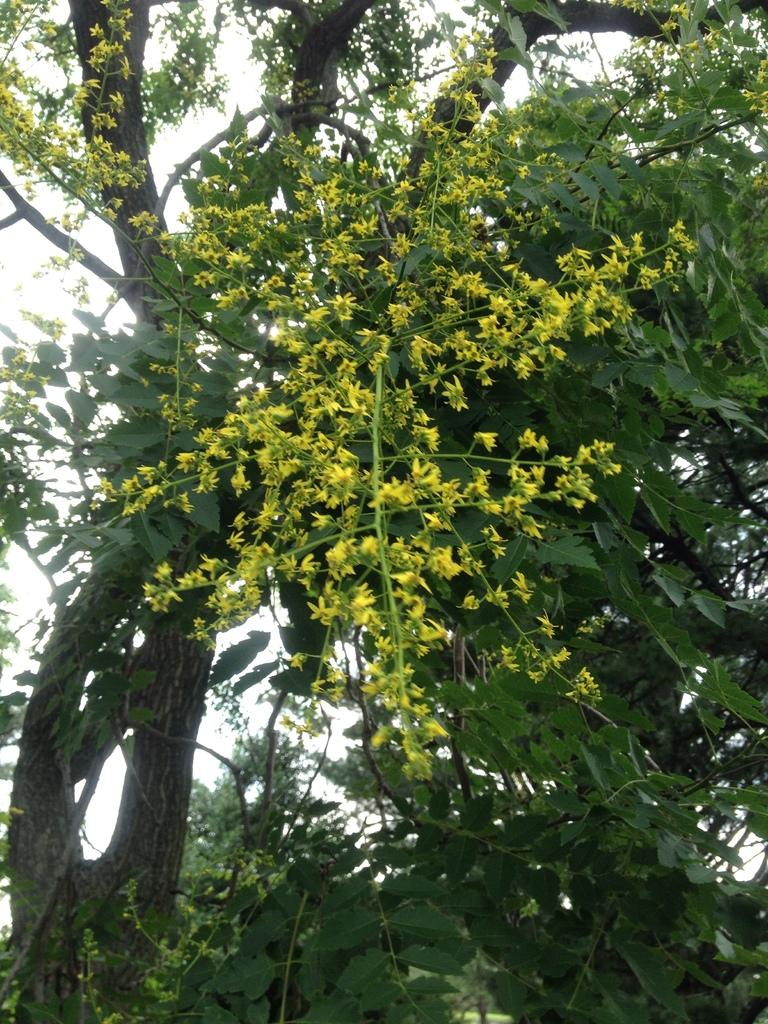What type of plant is visible in the image? There is a tree with leaves in the image. How does the tree affect the view of the sky? The tree is partially blocking the view of the sky. What type of teeth can be seen on the tree in the image? There are no teeth visible on the tree in the image, as trees do not have teeth. 